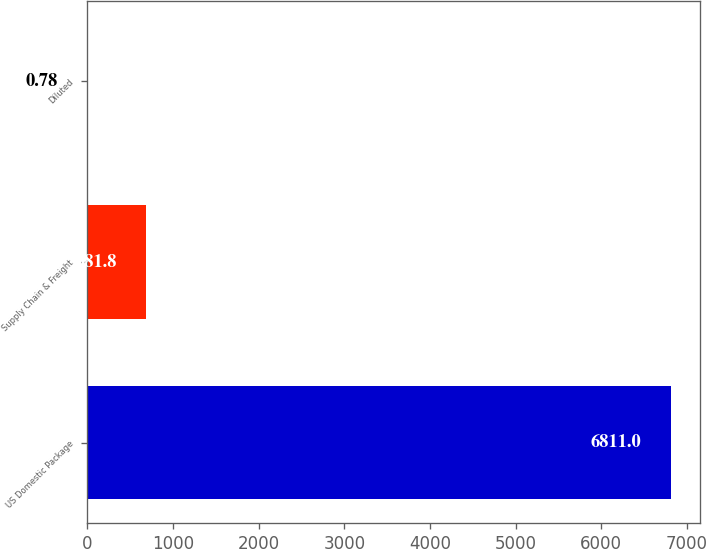<chart> <loc_0><loc_0><loc_500><loc_500><bar_chart><fcel>US Domestic Package<fcel>Supply Chain & Freight<fcel>Diluted<nl><fcel>6811<fcel>681.8<fcel>0.78<nl></chart> 